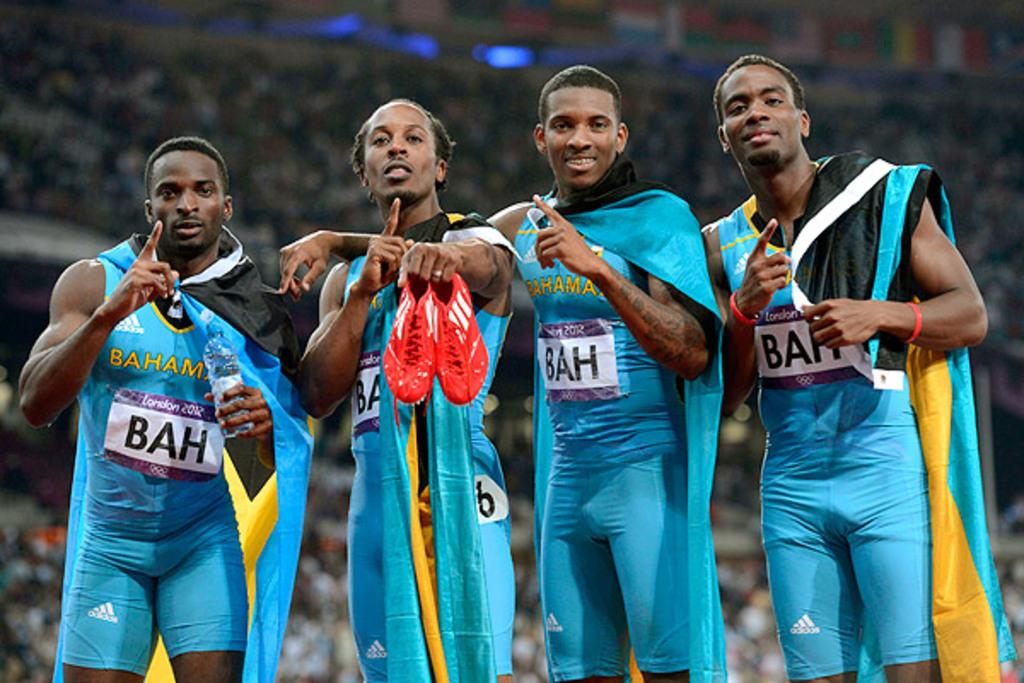<image>
Share a concise interpretation of the image provided. Olympic athletes from the Bahamas with their country's flag over their shoulders pose for a photograph. 